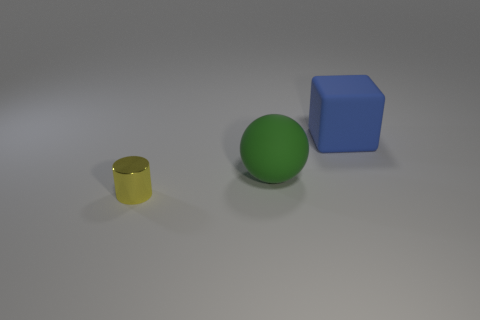There is a large object that is the same material as the block; what is its shape?
Keep it short and to the point. Sphere. Are there any other things of the same color as the tiny shiny cylinder?
Make the answer very short. No. What color is the big rubber thing that is in front of the blue matte object on the right side of the green sphere?
Your answer should be very brief. Green. What material is the big thing that is to the left of the large block that is right of the large rubber thing left of the large blue matte thing?
Give a very brief answer. Rubber. What number of matte balls are the same size as the yellow cylinder?
Your answer should be compact. 0. What material is the object that is both on the right side of the small yellow object and in front of the big matte block?
Keep it short and to the point. Rubber. What number of small yellow cylinders are on the left side of the yellow cylinder?
Your response must be concise. 0. Is the shape of the metallic object the same as the thing to the right of the green object?
Make the answer very short. No. Is there a yellow thing of the same shape as the green object?
Offer a terse response. No. What is the shape of the large thing that is behind the large rubber thing in front of the blue object?
Provide a succinct answer. Cube. 